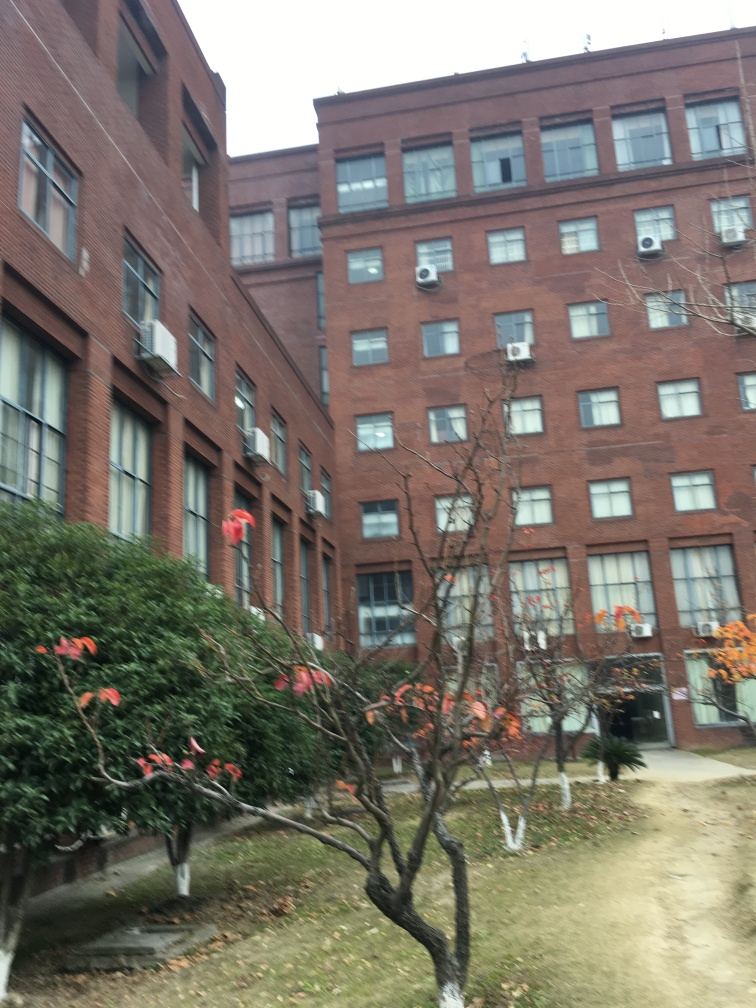Are the colors in this photo natural? While the colors in the photo appear somewhat natural, the quality and lighting conditions suggest the photo might be slightly overexposed, causing the colors to seem washed out. This may affect the fidelity of the colors to what would be perceived in person. 